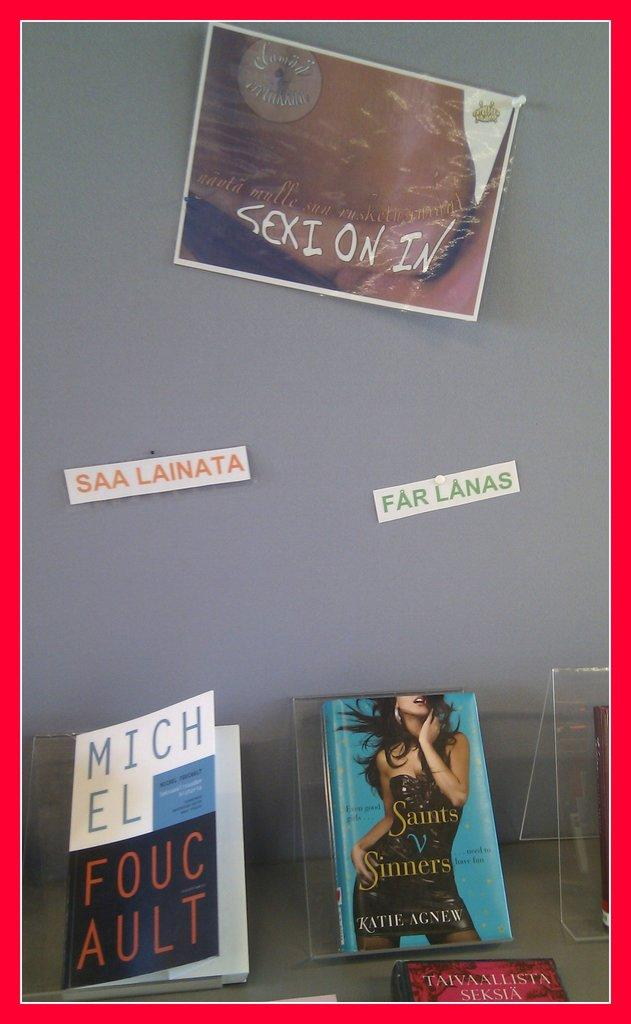What type of objects can be seen in the image? There are books and posters in the image. What is the background of the image? There is a wall in the image. What is the color of the border surrounding the image? The image has a red border. What type of silk is being used to drain the water in the image? There is no silk or water present in the image; it features books, posters, and a wall with a red border. 